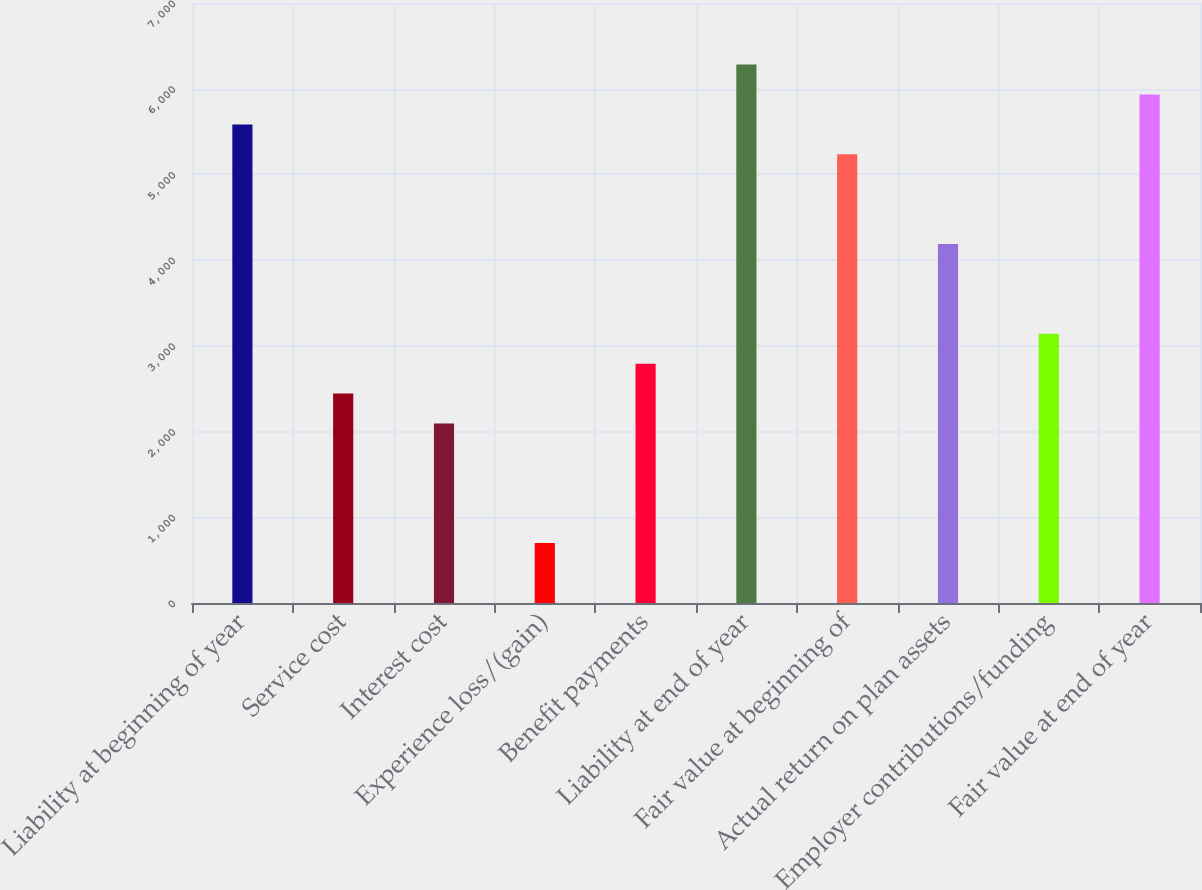<chart> <loc_0><loc_0><loc_500><loc_500><bar_chart><fcel>Liability at beginning of year<fcel>Service cost<fcel>Interest cost<fcel>Experience loss/(gain)<fcel>Benefit payments<fcel>Liability at end of year<fcel>Fair value at beginning of<fcel>Actual return on plan assets<fcel>Employer contributions/funding<fcel>Fair value at end of year<nl><fcel>5583.4<fcel>2443.3<fcel>2094.4<fcel>698.8<fcel>2792.2<fcel>6281.2<fcel>5234.5<fcel>4187.8<fcel>3141.1<fcel>5932.3<nl></chart> 